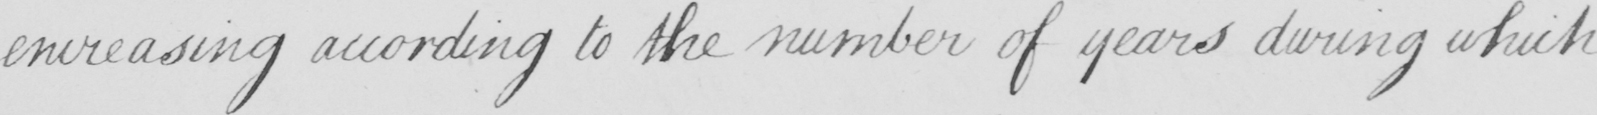Can you read and transcribe this handwriting? encreasing according to the number of years during which 